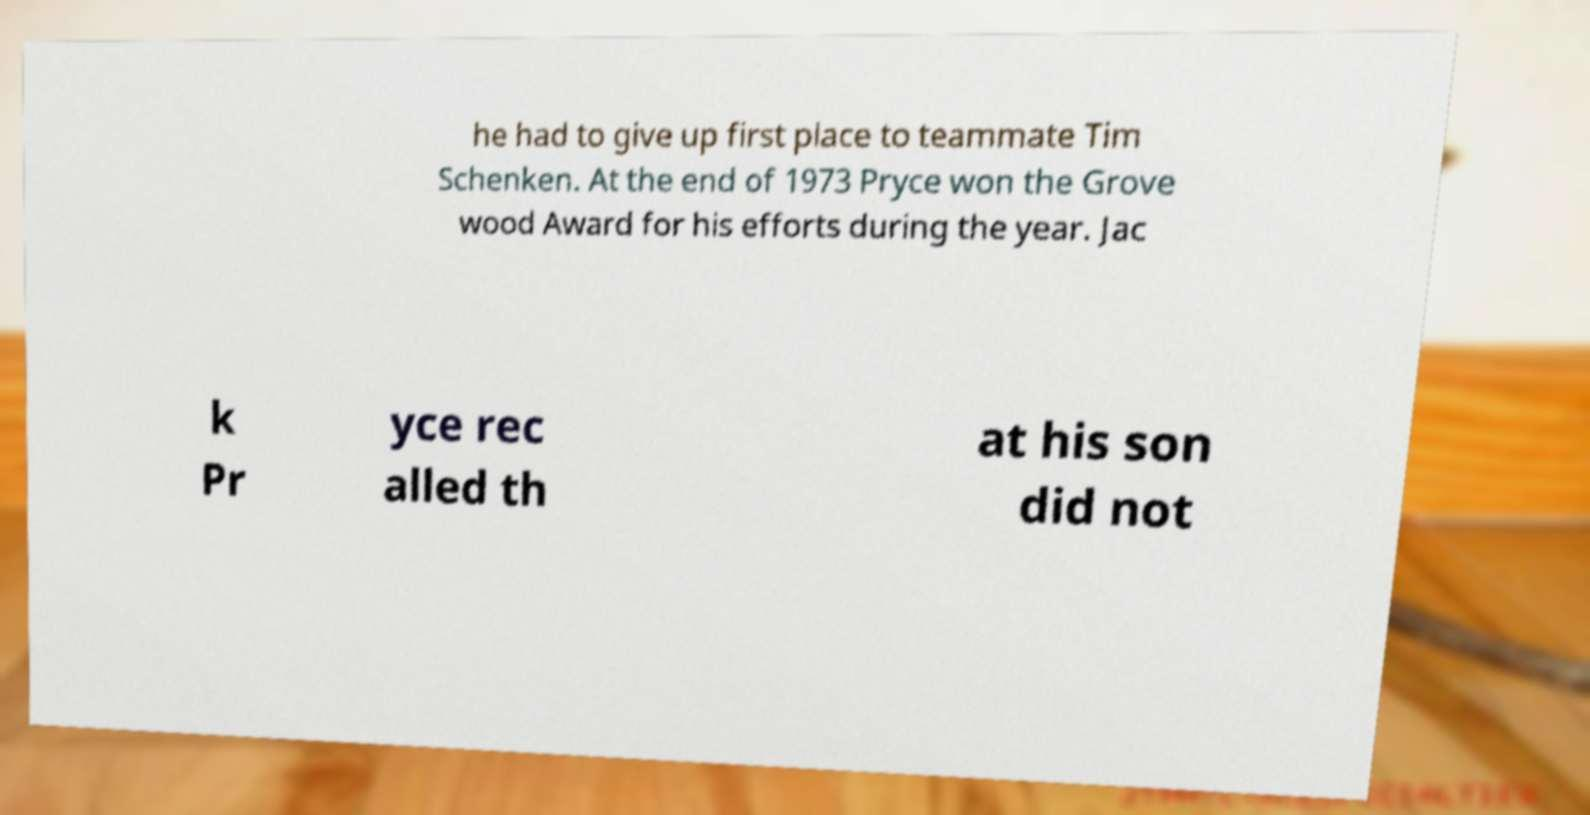Can you read and provide the text displayed in the image?This photo seems to have some interesting text. Can you extract and type it out for me? he had to give up first place to teammate Tim Schenken. At the end of 1973 Pryce won the Grove wood Award for his efforts during the year. Jac k Pr yce rec alled th at his son did not 